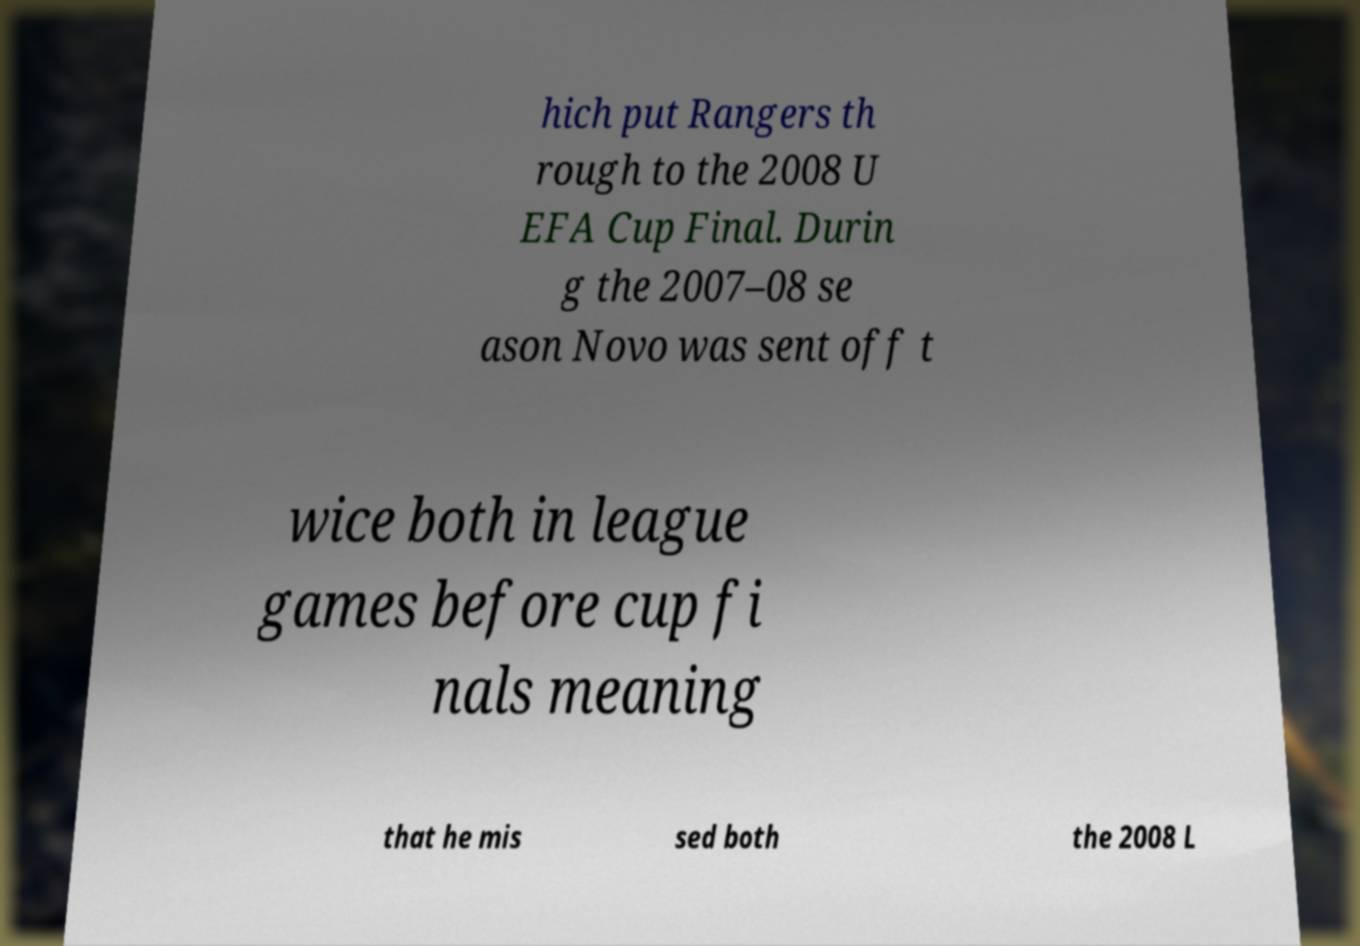There's text embedded in this image that I need extracted. Can you transcribe it verbatim? hich put Rangers th rough to the 2008 U EFA Cup Final. Durin g the 2007–08 se ason Novo was sent off t wice both in league games before cup fi nals meaning that he mis sed both the 2008 L 